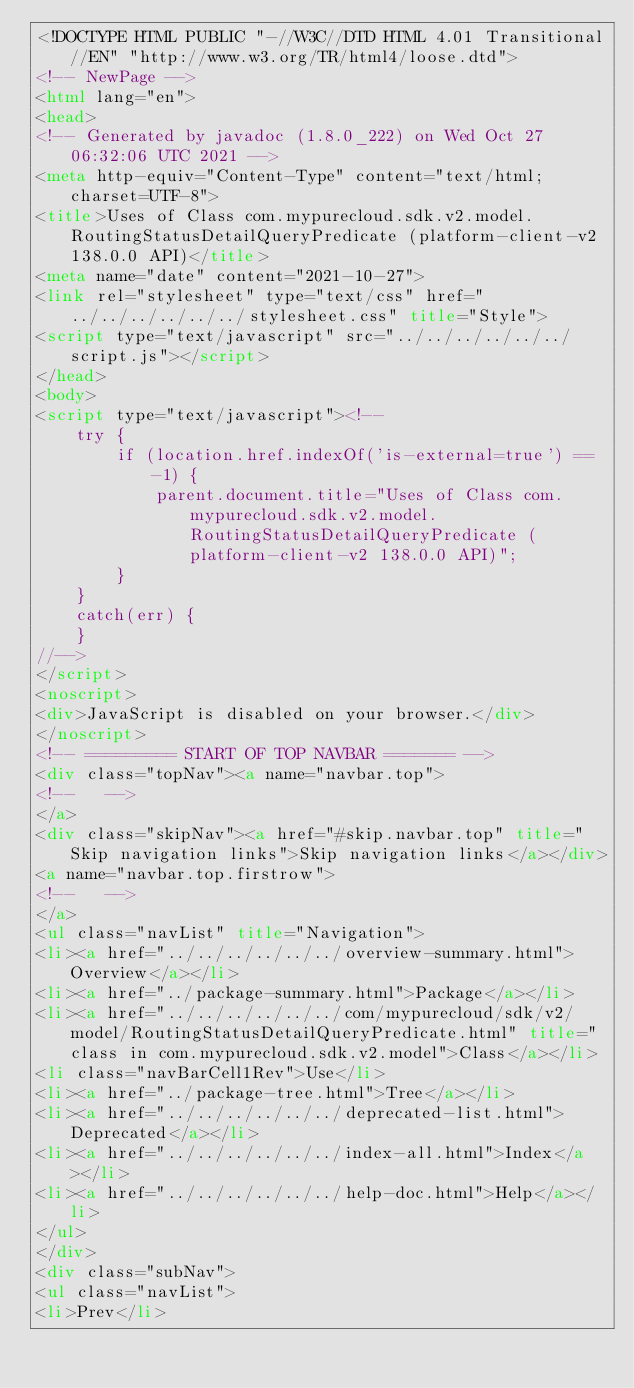<code> <loc_0><loc_0><loc_500><loc_500><_HTML_><!DOCTYPE HTML PUBLIC "-//W3C//DTD HTML 4.01 Transitional//EN" "http://www.w3.org/TR/html4/loose.dtd">
<!-- NewPage -->
<html lang="en">
<head>
<!-- Generated by javadoc (1.8.0_222) on Wed Oct 27 06:32:06 UTC 2021 -->
<meta http-equiv="Content-Type" content="text/html; charset=UTF-8">
<title>Uses of Class com.mypurecloud.sdk.v2.model.RoutingStatusDetailQueryPredicate (platform-client-v2 138.0.0 API)</title>
<meta name="date" content="2021-10-27">
<link rel="stylesheet" type="text/css" href="../../../../../../stylesheet.css" title="Style">
<script type="text/javascript" src="../../../../../../script.js"></script>
</head>
<body>
<script type="text/javascript"><!--
    try {
        if (location.href.indexOf('is-external=true') == -1) {
            parent.document.title="Uses of Class com.mypurecloud.sdk.v2.model.RoutingStatusDetailQueryPredicate (platform-client-v2 138.0.0 API)";
        }
    }
    catch(err) {
    }
//-->
</script>
<noscript>
<div>JavaScript is disabled on your browser.</div>
</noscript>
<!-- ========= START OF TOP NAVBAR ======= -->
<div class="topNav"><a name="navbar.top">
<!--   -->
</a>
<div class="skipNav"><a href="#skip.navbar.top" title="Skip navigation links">Skip navigation links</a></div>
<a name="navbar.top.firstrow">
<!--   -->
</a>
<ul class="navList" title="Navigation">
<li><a href="../../../../../../overview-summary.html">Overview</a></li>
<li><a href="../package-summary.html">Package</a></li>
<li><a href="../../../../../../com/mypurecloud/sdk/v2/model/RoutingStatusDetailQueryPredicate.html" title="class in com.mypurecloud.sdk.v2.model">Class</a></li>
<li class="navBarCell1Rev">Use</li>
<li><a href="../package-tree.html">Tree</a></li>
<li><a href="../../../../../../deprecated-list.html">Deprecated</a></li>
<li><a href="../../../../../../index-all.html">Index</a></li>
<li><a href="../../../../../../help-doc.html">Help</a></li>
</ul>
</div>
<div class="subNav">
<ul class="navList">
<li>Prev</li></code> 